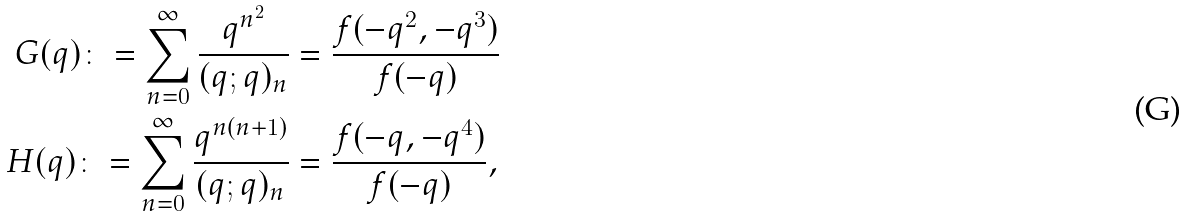<formula> <loc_0><loc_0><loc_500><loc_500>G ( q ) \colon = \sum _ { n = 0 } ^ { \infty } \frac { q ^ { n ^ { 2 } } } { ( q ; q ) _ { n } } & = \frac { f ( - q ^ { 2 } , - q ^ { 3 } ) } { f ( - q ) } \\ H ( q ) \colon = \sum _ { n = 0 } ^ { \infty } \frac { q ^ { n ( n + 1 ) } } { ( q ; q ) _ { n } } & = \frac { f ( - q , - q ^ { 4 } ) } { f ( - q ) } ,</formula> 